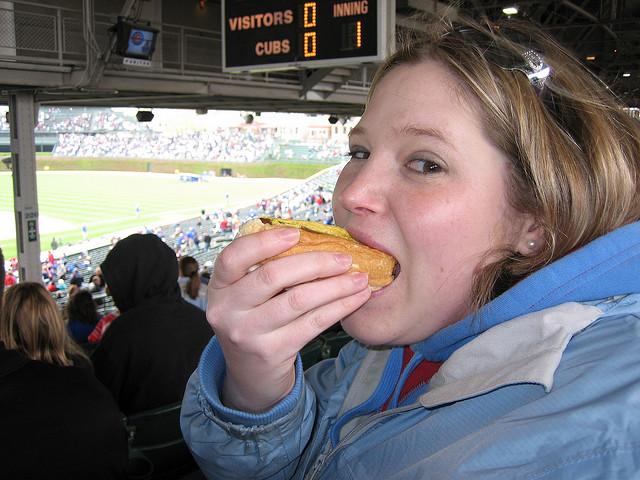What is the woman eating?
Quick response, please. Hot dog. Is she at a basketball game?
Write a very short answer. No. What is the score?
Give a very brief answer. 0-0. 